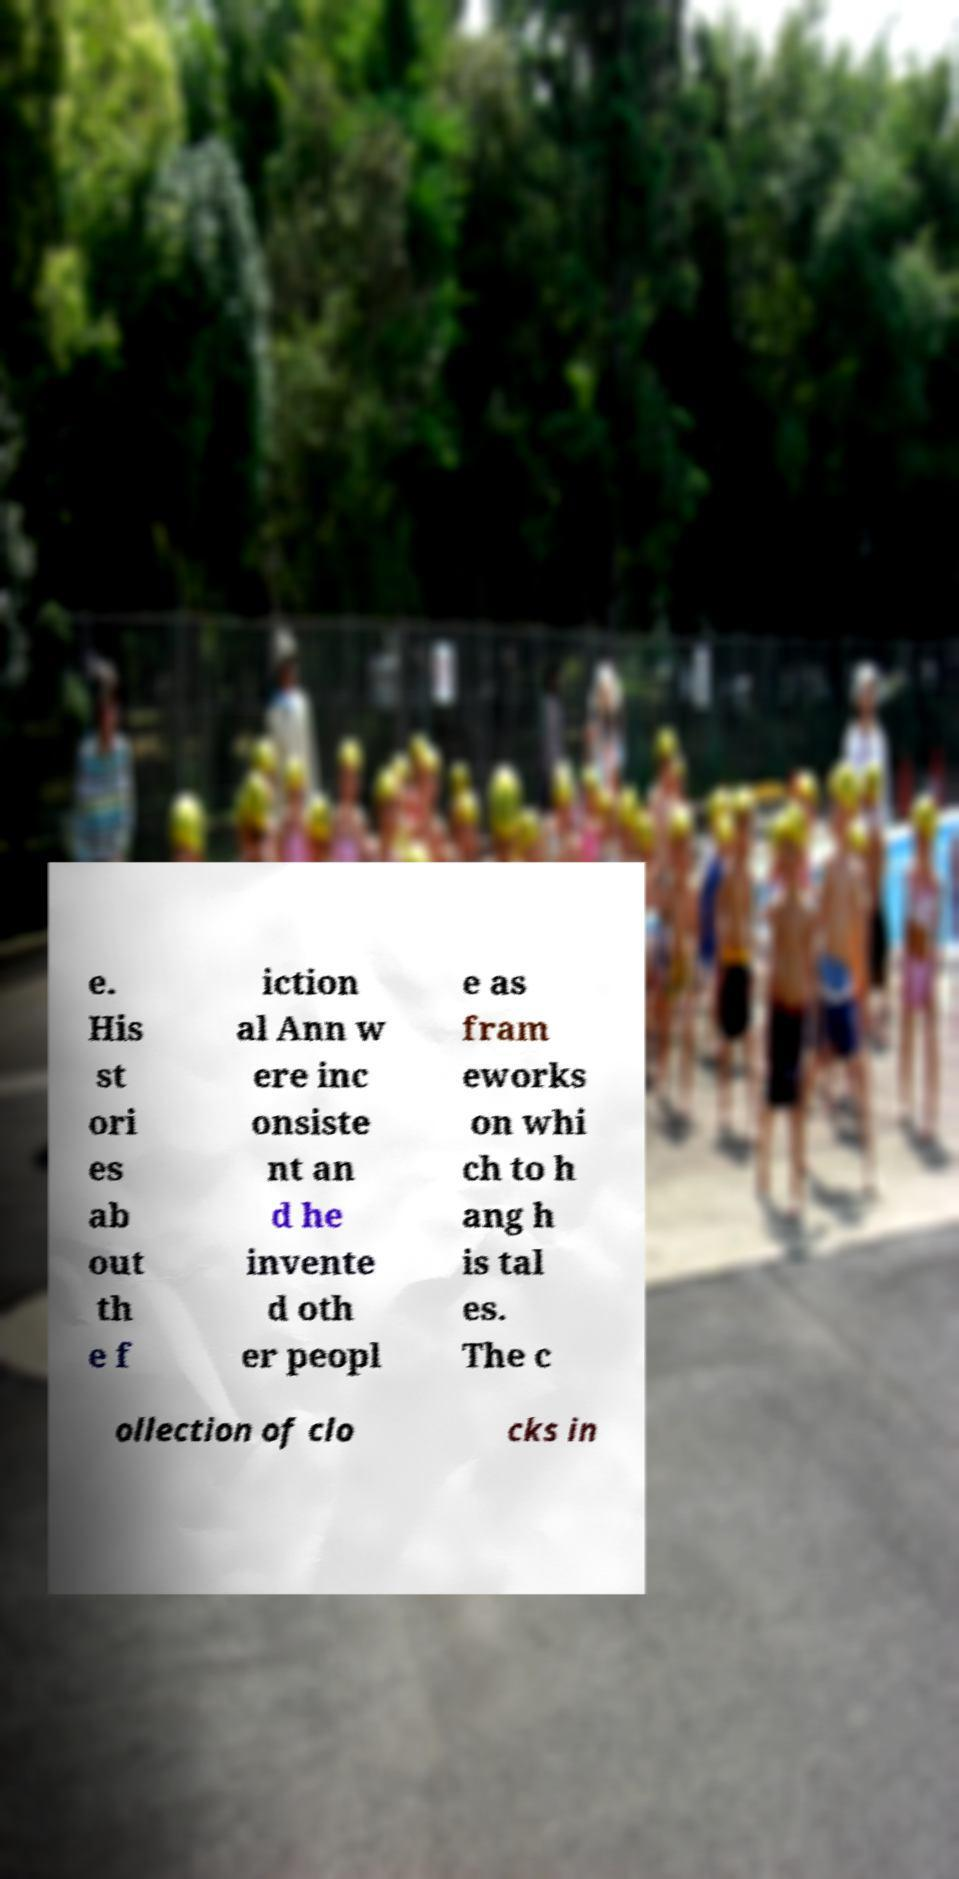There's text embedded in this image that I need extracted. Can you transcribe it verbatim? e. His st ori es ab out th e f iction al Ann w ere inc onsiste nt an d he invente d oth er peopl e as fram eworks on whi ch to h ang h is tal es. The c ollection of clo cks in 